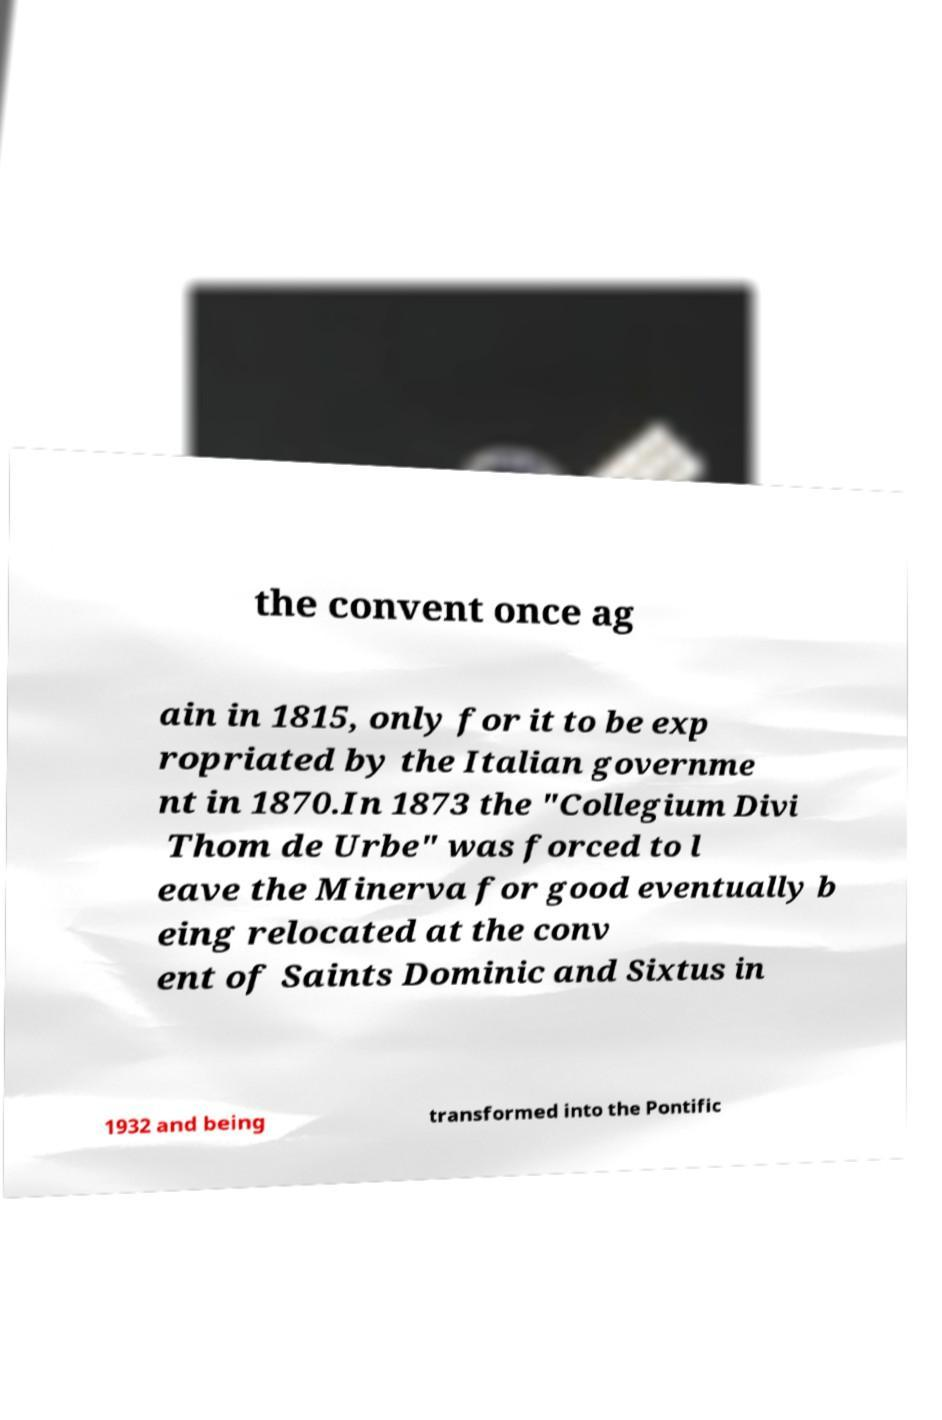Please read and relay the text visible in this image. What does it say? the convent once ag ain in 1815, only for it to be exp ropriated by the Italian governme nt in 1870.In 1873 the "Collegium Divi Thom de Urbe" was forced to l eave the Minerva for good eventually b eing relocated at the conv ent of Saints Dominic and Sixtus in 1932 and being transformed into the Pontific 